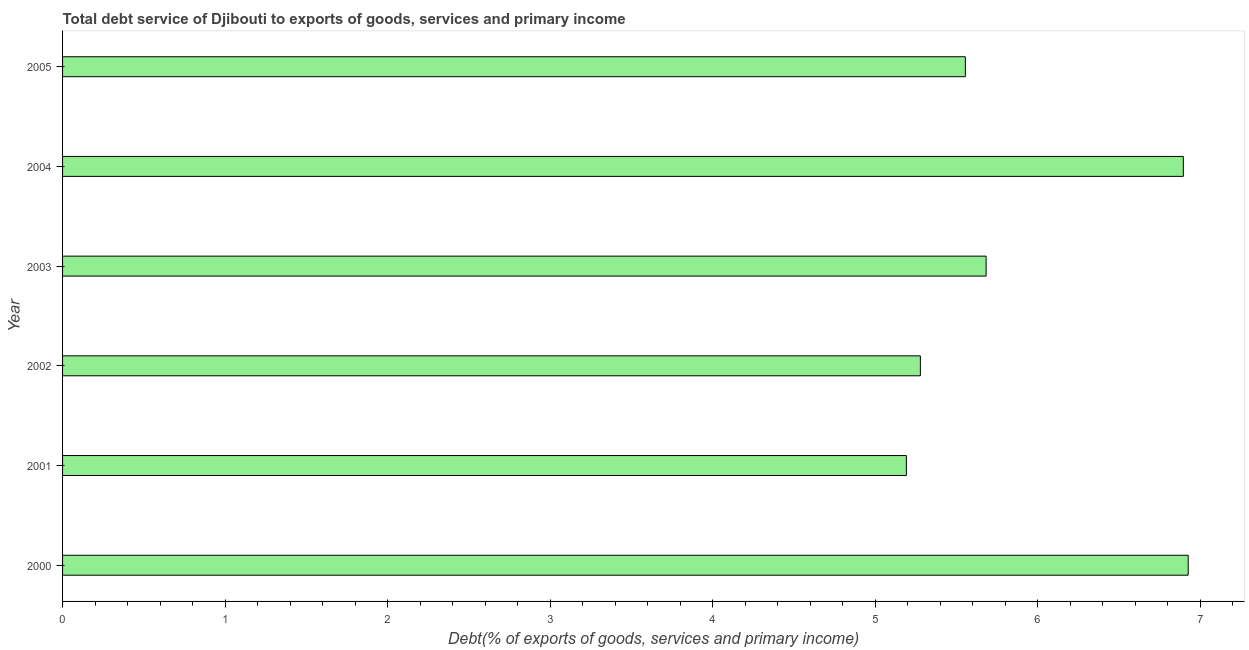Does the graph contain grids?
Keep it short and to the point. No. What is the title of the graph?
Offer a terse response. Total debt service of Djibouti to exports of goods, services and primary income. What is the label or title of the X-axis?
Your response must be concise. Debt(% of exports of goods, services and primary income). What is the total debt service in 2000?
Offer a terse response. 6.93. Across all years, what is the maximum total debt service?
Keep it short and to the point. 6.93. Across all years, what is the minimum total debt service?
Provide a succinct answer. 5.19. What is the sum of the total debt service?
Offer a very short reply. 35.53. What is the difference between the total debt service in 2001 and 2005?
Your answer should be compact. -0.36. What is the average total debt service per year?
Your response must be concise. 5.92. What is the median total debt service?
Provide a succinct answer. 5.62. Do a majority of the years between 2002 and 2004 (inclusive) have total debt service greater than 3.8 %?
Your answer should be very brief. Yes. What is the ratio of the total debt service in 2001 to that in 2002?
Ensure brevity in your answer.  0.98. Is the sum of the total debt service in 2004 and 2005 greater than the maximum total debt service across all years?
Keep it short and to the point. Yes. What is the difference between the highest and the lowest total debt service?
Keep it short and to the point. 1.73. In how many years, is the total debt service greater than the average total debt service taken over all years?
Offer a terse response. 2. How many bars are there?
Your response must be concise. 6. What is the difference between two consecutive major ticks on the X-axis?
Provide a short and direct response. 1. Are the values on the major ticks of X-axis written in scientific E-notation?
Ensure brevity in your answer.  No. What is the Debt(% of exports of goods, services and primary income) in 2000?
Give a very brief answer. 6.93. What is the Debt(% of exports of goods, services and primary income) in 2001?
Your answer should be very brief. 5.19. What is the Debt(% of exports of goods, services and primary income) in 2002?
Ensure brevity in your answer.  5.28. What is the Debt(% of exports of goods, services and primary income) of 2003?
Provide a succinct answer. 5.68. What is the Debt(% of exports of goods, services and primary income) of 2004?
Give a very brief answer. 6.9. What is the Debt(% of exports of goods, services and primary income) of 2005?
Ensure brevity in your answer.  5.55. What is the difference between the Debt(% of exports of goods, services and primary income) in 2000 and 2001?
Your answer should be compact. 1.73. What is the difference between the Debt(% of exports of goods, services and primary income) in 2000 and 2002?
Give a very brief answer. 1.65. What is the difference between the Debt(% of exports of goods, services and primary income) in 2000 and 2003?
Your response must be concise. 1.24. What is the difference between the Debt(% of exports of goods, services and primary income) in 2000 and 2004?
Your answer should be very brief. 0.03. What is the difference between the Debt(% of exports of goods, services and primary income) in 2000 and 2005?
Provide a short and direct response. 1.37. What is the difference between the Debt(% of exports of goods, services and primary income) in 2001 and 2002?
Give a very brief answer. -0.09. What is the difference between the Debt(% of exports of goods, services and primary income) in 2001 and 2003?
Provide a short and direct response. -0.49. What is the difference between the Debt(% of exports of goods, services and primary income) in 2001 and 2004?
Offer a terse response. -1.7. What is the difference between the Debt(% of exports of goods, services and primary income) in 2001 and 2005?
Your response must be concise. -0.36. What is the difference between the Debt(% of exports of goods, services and primary income) in 2002 and 2003?
Offer a very short reply. -0.4. What is the difference between the Debt(% of exports of goods, services and primary income) in 2002 and 2004?
Ensure brevity in your answer.  -1.62. What is the difference between the Debt(% of exports of goods, services and primary income) in 2002 and 2005?
Keep it short and to the point. -0.28. What is the difference between the Debt(% of exports of goods, services and primary income) in 2003 and 2004?
Offer a terse response. -1.21. What is the difference between the Debt(% of exports of goods, services and primary income) in 2003 and 2005?
Offer a terse response. 0.13. What is the difference between the Debt(% of exports of goods, services and primary income) in 2004 and 2005?
Ensure brevity in your answer.  1.34. What is the ratio of the Debt(% of exports of goods, services and primary income) in 2000 to that in 2001?
Ensure brevity in your answer.  1.33. What is the ratio of the Debt(% of exports of goods, services and primary income) in 2000 to that in 2002?
Your response must be concise. 1.31. What is the ratio of the Debt(% of exports of goods, services and primary income) in 2000 to that in 2003?
Your response must be concise. 1.22. What is the ratio of the Debt(% of exports of goods, services and primary income) in 2000 to that in 2004?
Your response must be concise. 1. What is the ratio of the Debt(% of exports of goods, services and primary income) in 2000 to that in 2005?
Provide a succinct answer. 1.25. What is the ratio of the Debt(% of exports of goods, services and primary income) in 2001 to that in 2002?
Offer a terse response. 0.98. What is the ratio of the Debt(% of exports of goods, services and primary income) in 2001 to that in 2003?
Give a very brief answer. 0.91. What is the ratio of the Debt(% of exports of goods, services and primary income) in 2001 to that in 2004?
Offer a terse response. 0.75. What is the ratio of the Debt(% of exports of goods, services and primary income) in 2001 to that in 2005?
Offer a very short reply. 0.94. What is the ratio of the Debt(% of exports of goods, services and primary income) in 2002 to that in 2003?
Keep it short and to the point. 0.93. What is the ratio of the Debt(% of exports of goods, services and primary income) in 2002 to that in 2004?
Offer a very short reply. 0.77. What is the ratio of the Debt(% of exports of goods, services and primary income) in 2002 to that in 2005?
Make the answer very short. 0.95. What is the ratio of the Debt(% of exports of goods, services and primary income) in 2003 to that in 2004?
Provide a short and direct response. 0.82. What is the ratio of the Debt(% of exports of goods, services and primary income) in 2004 to that in 2005?
Make the answer very short. 1.24. 